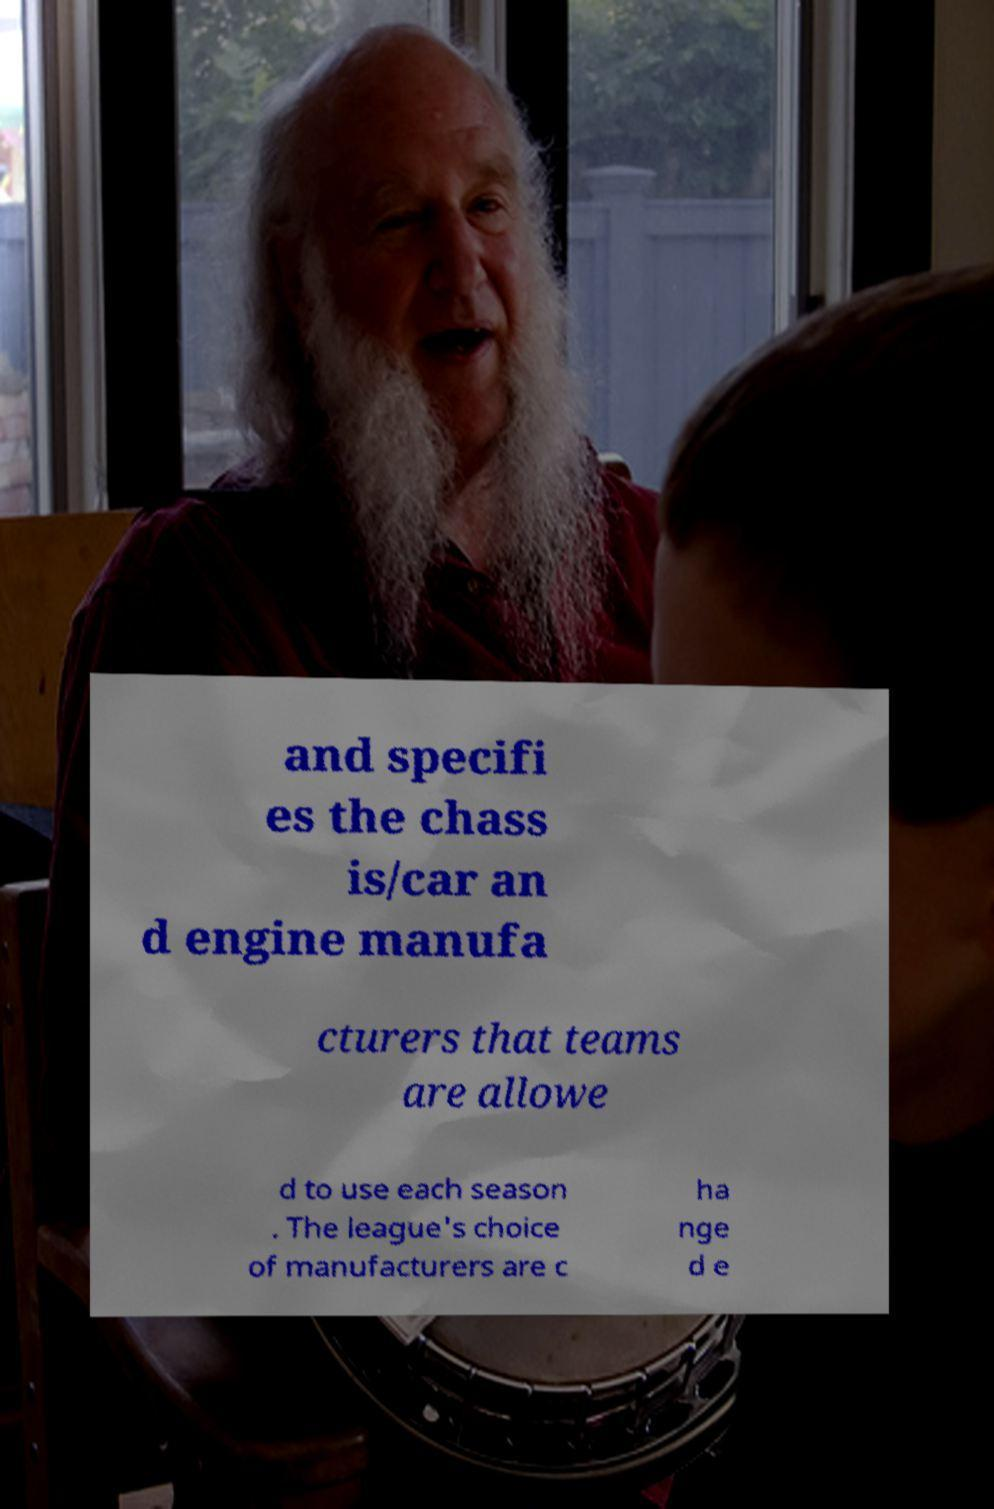There's text embedded in this image that I need extracted. Can you transcribe it verbatim? and specifi es the chass is/car an d engine manufa cturers that teams are allowe d to use each season . The league's choice of manufacturers are c ha nge d e 